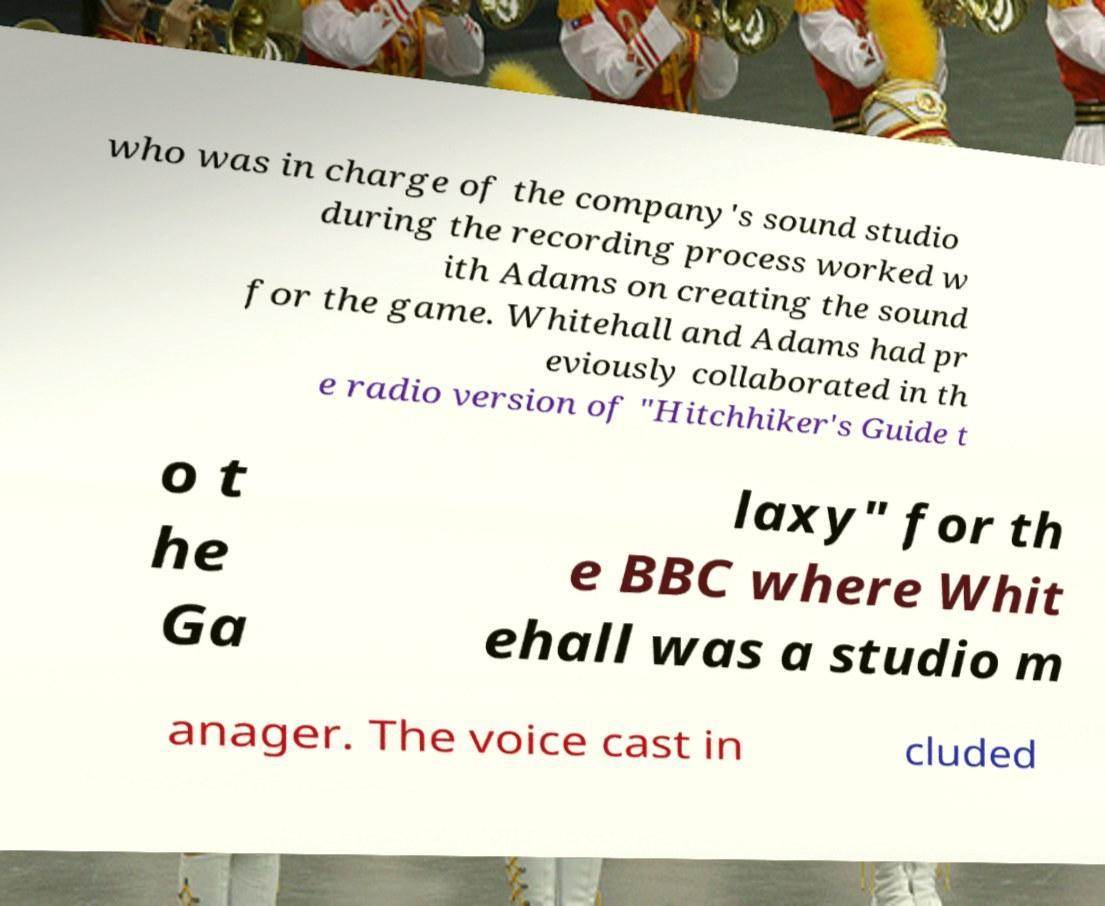Could you extract and type out the text from this image? who was in charge of the company's sound studio during the recording process worked w ith Adams on creating the sound for the game. Whitehall and Adams had pr eviously collaborated in th e radio version of "Hitchhiker's Guide t o t he Ga laxy" for th e BBC where Whit ehall was a studio m anager. The voice cast in cluded 